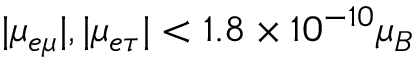<formula> <loc_0><loc_0><loc_500><loc_500>| \mu _ { e \mu } | , | \mu _ { e \tau } | < 1 . 8 \times 1 0 ^ { - 1 0 } \mu _ { B }</formula> 